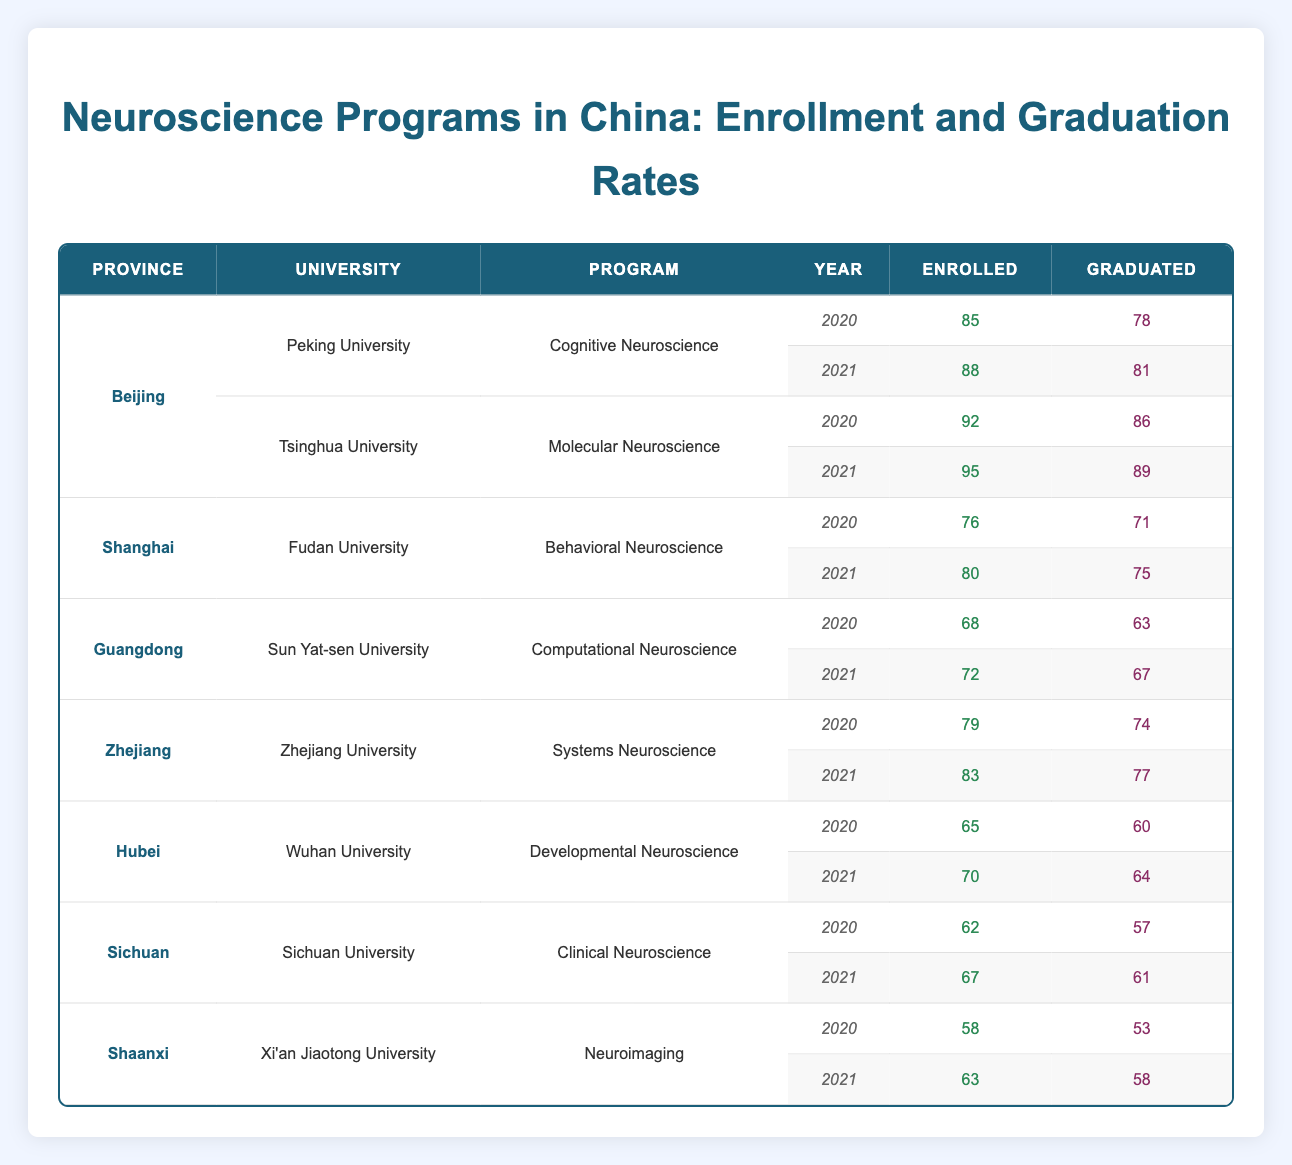What was the graduation rate for Peking University in 2021? For Peking University in 2021, the number of graduates is 81 and the number of enrolled students is 88. The graduation rate is calculated as (Graduated/Enrolled) * 100 = (81/88) * 100 = 92.05%.
Answer: 92.05% Which university had the highest enrollment in 2020? By looking through the table, Tsinghua University had 92 enrolled students in 2020, which is higher than the enrollment numbers of other universities for that year.
Answer: Tsinghua University What is the overall trend in enrollment numbers for neuroscience programs from 2020 to 2021? To determine the trend, we can compare the enrollment numbers for 2020 and 2021 across all universities. For example: Peking University: 85 to 88, Tsinghua University: 92 to 95, Fudan University: 76 to 80, etc. This shows consistent growth in each institution's enrollment.
Answer: Increasing trend Did any university demonstrate a decrease in graduation rates from 2020 to 2021? We need to analyze the graduation rates for the years specified. For instance, at Fudan University, the number of graduates was 71 in 2020 and 75 in 2021, showing an increase. A decrease is observed at Sichuan University, where graduates went from 57 in 2020 to 61 in 2021, with a specific batch that didn't show a drop. Hence, there were no decreases observed.
Answer: No What was the average number of enrolled students across all universities for 2020? We sum up all enrolled students for 2020, which are 85 (Peking), 92 (Tsinghua), 76 (Fudan), 68 (Sun Yat-sen), 79 (Zhejiang), 65 (Wuhan), 62 (Sichuan), and 58 (Xi'an Jiaotong) = 585. Then we divide by the number of universities (8) to get the average: 585/8 = 73.125.
Answer: 73.125 Which province had the highest total number of graduates in 2021? Summing graduates for each province in 2021, we find: Beijing (81+89=170), Shanghai (75), Guangdong (67), Zhejiang (77), Hubei (64), Sichuan (61), and Shaanxi (58). The highest total is from Beijing with 170 graduates.
Answer: Beijing What percentage of students graduated from the Cognitive Neuroscience program at Peking University in 2020? The number of students who graduated from that program in 2020 was 78, while the total number enrolled was 85. Therefore, the graduation rate is (78/85) * 100 = 91.76%.
Answer: 91.76% Was there an increase in the enrollment numbers for Neuroscience programs in Hubei from 2020 to 2021? Comparing Hubei's enrollment: 65 in 2020 vs. 70 in 2021 shows an increase of 5 students, confirming this.
Answer: Yes What was the difference in the number of enrolled students between Xi'an Jiaotong University in 2020 and 2021? The enrollment in 2020 was 58, and in 2021, it was 63. The difference is calculated as 63 - 58 = 5.
Answer: 5 